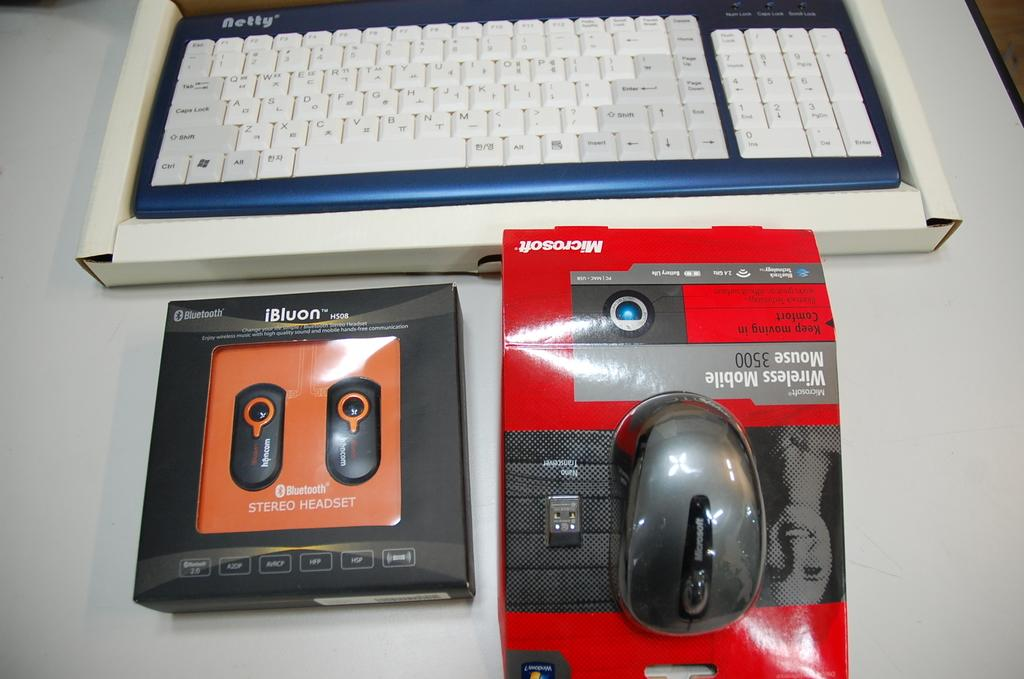What type of device is visible in the image? There is a keyboard in the image. What is the other device that can be seen in the image? There is a mouse in the image. What is the third item related to technology in the image? There is a headset in the image. Where are all these items located in the image? All items are placed on a table. What type of ball is being used to play a game in the image? There is no ball present in the image; it features a keyboard, mouse, and headset on a table. 